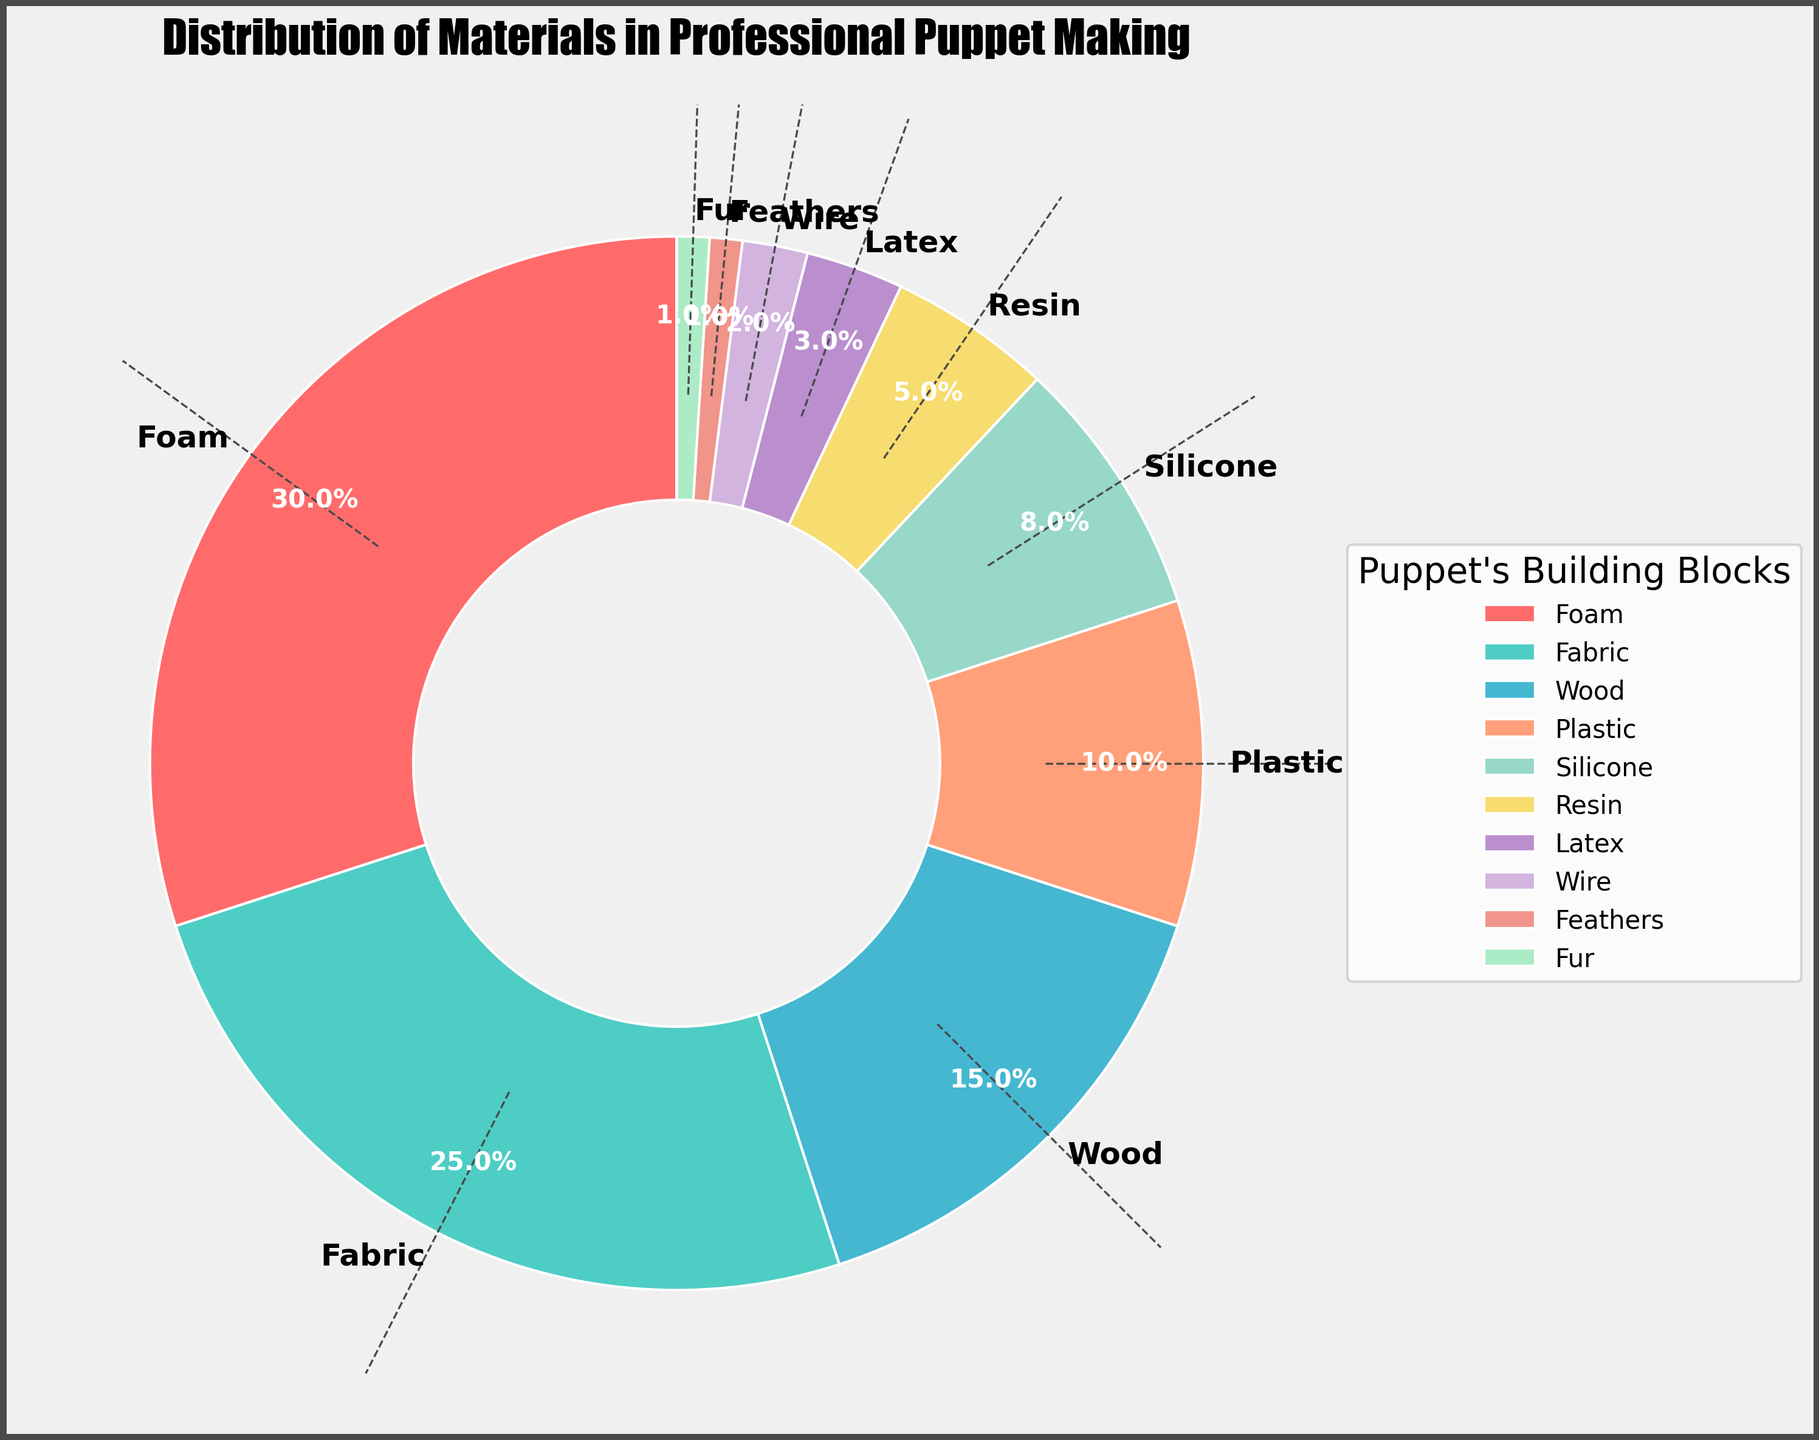What is the most used material in professional puppet making? The slice representing "Foam" is the largest segment in the pie chart, covering 30% of the distribution, making it the most used material.
Answer: Foam Which material is used the least and how much is it used? The slices representing "Feathers" and "Fur" are the smallest segments in the pie chart, each covering 1% of the distribution, indicating they are the least used materials.
Answer: Feathers and Fur, 1% How much more foam is used compared to latex? The slice for "Foam" covers 30% and the slice for "Latex" covers 3%. The difference between them is 30% - 3% = 27%.
Answer: 27% If "Fabric" and "Wood" usage percentages are combined, what would be their total? The slice for "Fabric" covers 25% and the slice for "Wood" covers 15%. Their combined total is 25% + 15% = 40%.
Answer: 40% Which material combination makes up roughly half of the distribution? The sum of "Foam" (30%) and "Fabric" (25%) is 55%, which is slightly more than half of the distribution.
Answer: Foam and Fabric Which material has a larger percentage usage: Plastics or Silicone? The slice for "Plastic" covers 10%, while the slice for "Silicone" covers 8%. Therefore, "Plastic" has a larger percentage usage.
Answer: Plastic What is the total percentage for materials used less than 5% each? "Resin" (5%), "Latex" (3%), "Wire" (2%), "Feathers" (1%), and "Fur" (1%) sum up to 5% + 3% + 2% + 1% + 1% = 12%.
Answer: 12% Among the materials listed, which color represents the segment containing "Wood"? The slice for "Wood" is visually distinct and colored as light blue/cyan.
Answer: Light Blue/Cyan How many materials have a usage percentage higher than 20%? The slices representing "Foam" (30%) and "Fabric" (25%) are the only ones with a usage percentage higher than 20%. There are 2 such materials.
Answer: 2 